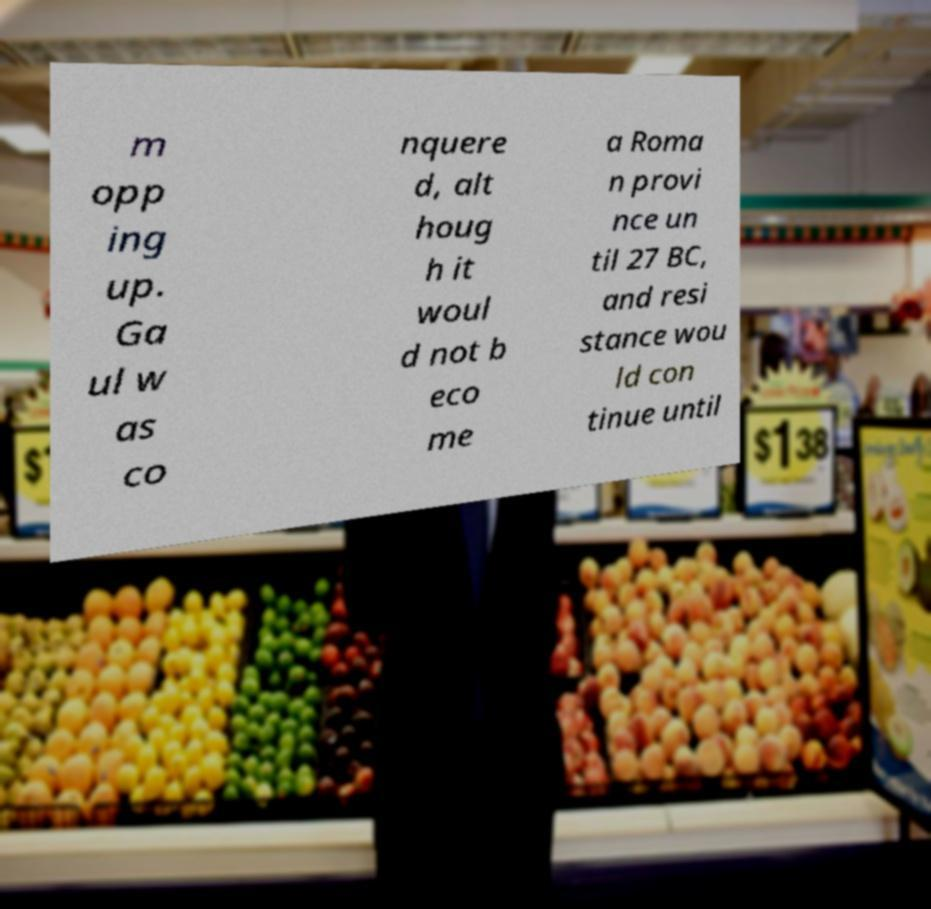Can you accurately transcribe the text from the provided image for me? m opp ing up. Ga ul w as co nquere d, alt houg h it woul d not b eco me a Roma n provi nce un til 27 BC, and resi stance wou ld con tinue until 